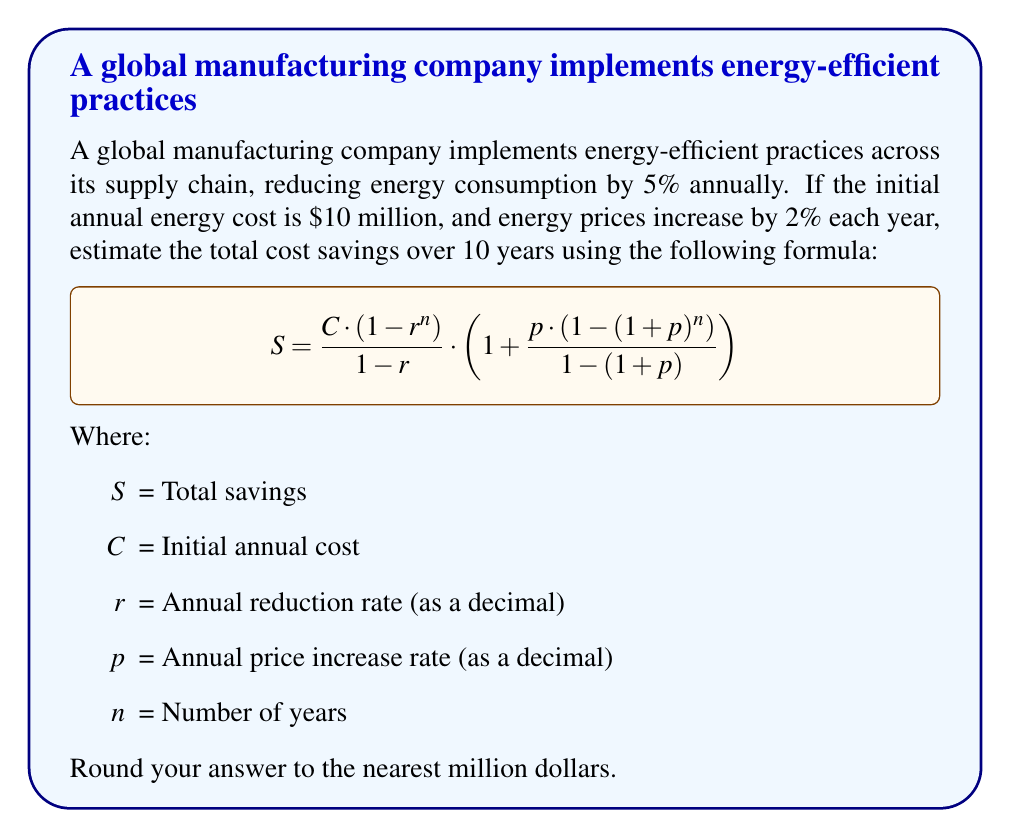Give your solution to this math problem. Let's solve this problem step-by-step:

1) First, let's identify our variables:
   $C = 10,000,000$ (initial annual cost)
   $r = 0.95$ (1 - 0.05, as we're reducing by 5% annually)
   $p = 0.02$ (2% annual price increase)
   $n = 10$ (years)

2) Now, let's substitute these values into our formula:

   $$S = \frac{10,000,000 \cdot (1 - 0.95^{10})}{1 - 0.95} \cdot \left(1 + \frac{0.02 \cdot (1 - (1+0.02)^{10})}{1 - (1+0.02)}\right)$$

3) Let's solve the parts inside the parentheses first:
   
   $0.95^{10} \approx 0.5987$
   $(1+0.02)^{10} \approx 1.2190$

4) Now our equation looks like this:

   $$S = \frac{10,000,000 \cdot (1 - 0.5987)}{1 - 0.95} \cdot \left(1 + \frac{0.02 \cdot (1 - 1.2190)}{1 - 1.02}\right)$$

5) Simplify:

   $$S = \frac{10,000,000 \cdot 0.4013}{0.05} \cdot \left(1 + \frac{0.02 \cdot (-0.2190)}{-0.02}\right)$$

6) Calculate:

   $$S = 80,260,000 \cdot (1 + 0.2190) = 80,260,000 \cdot 1.2190 = 97,836,940$$

7) Rounding to the nearest million:

   $S \approx 98,000,000$
Answer: $98 million 